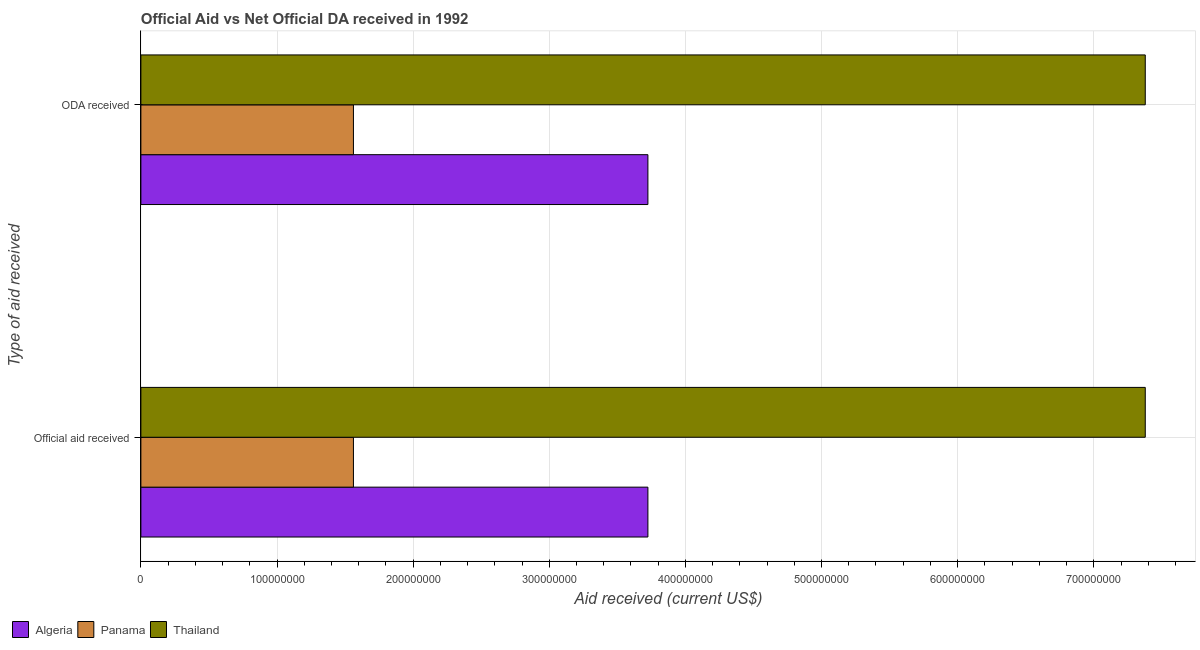How many different coloured bars are there?
Your answer should be compact. 3. How many groups of bars are there?
Give a very brief answer. 2. Are the number of bars per tick equal to the number of legend labels?
Provide a succinct answer. Yes. What is the label of the 2nd group of bars from the top?
Offer a terse response. Official aid received. What is the oda received in Panama?
Make the answer very short. 1.56e+08. Across all countries, what is the maximum oda received?
Offer a terse response. 7.38e+08. Across all countries, what is the minimum oda received?
Ensure brevity in your answer.  1.56e+08. In which country was the official aid received maximum?
Your response must be concise. Thailand. In which country was the oda received minimum?
Offer a very short reply. Panama. What is the total official aid received in the graph?
Make the answer very short. 1.27e+09. What is the difference between the oda received in Panama and that in Algeria?
Your response must be concise. -2.16e+08. What is the difference between the oda received in Thailand and the official aid received in Algeria?
Give a very brief answer. 3.65e+08. What is the average official aid received per country?
Make the answer very short. 4.22e+08. What is the difference between the official aid received and oda received in Thailand?
Keep it short and to the point. 0. What is the ratio of the official aid received in Algeria to that in Panama?
Provide a short and direct response. 2.39. Is the official aid received in Thailand less than that in Panama?
Your answer should be compact. No. What does the 2nd bar from the top in Official aid received represents?
Offer a terse response. Panama. What does the 2nd bar from the bottom in ODA received represents?
Provide a short and direct response. Panama. How many countries are there in the graph?
Provide a short and direct response. 3. What is the difference between two consecutive major ticks on the X-axis?
Your answer should be very brief. 1.00e+08. Does the graph contain grids?
Give a very brief answer. Yes. Where does the legend appear in the graph?
Keep it short and to the point. Bottom left. How are the legend labels stacked?
Offer a very short reply. Horizontal. What is the title of the graph?
Your answer should be very brief. Official Aid vs Net Official DA received in 1992 . Does "Morocco" appear as one of the legend labels in the graph?
Your answer should be very brief. No. What is the label or title of the X-axis?
Keep it short and to the point. Aid received (current US$). What is the label or title of the Y-axis?
Offer a terse response. Type of aid received. What is the Aid received (current US$) in Algeria in Official aid received?
Provide a succinct answer. 3.72e+08. What is the Aid received (current US$) of Panama in Official aid received?
Offer a terse response. 1.56e+08. What is the Aid received (current US$) in Thailand in Official aid received?
Ensure brevity in your answer.  7.38e+08. What is the Aid received (current US$) of Algeria in ODA received?
Provide a short and direct response. 3.72e+08. What is the Aid received (current US$) in Panama in ODA received?
Keep it short and to the point. 1.56e+08. What is the Aid received (current US$) in Thailand in ODA received?
Your answer should be very brief. 7.38e+08. Across all Type of aid received, what is the maximum Aid received (current US$) of Algeria?
Provide a succinct answer. 3.72e+08. Across all Type of aid received, what is the maximum Aid received (current US$) of Panama?
Keep it short and to the point. 1.56e+08. Across all Type of aid received, what is the maximum Aid received (current US$) in Thailand?
Provide a succinct answer. 7.38e+08. Across all Type of aid received, what is the minimum Aid received (current US$) in Algeria?
Offer a very short reply. 3.72e+08. Across all Type of aid received, what is the minimum Aid received (current US$) in Panama?
Provide a short and direct response. 1.56e+08. Across all Type of aid received, what is the minimum Aid received (current US$) of Thailand?
Offer a very short reply. 7.38e+08. What is the total Aid received (current US$) in Algeria in the graph?
Your answer should be very brief. 7.45e+08. What is the total Aid received (current US$) of Panama in the graph?
Give a very brief answer. 3.12e+08. What is the total Aid received (current US$) in Thailand in the graph?
Your answer should be very brief. 1.48e+09. What is the difference between the Aid received (current US$) in Algeria in Official aid received and the Aid received (current US$) in Panama in ODA received?
Provide a short and direct response. 2.16e+08. What is the difference between the Aid received (current US$) of Algeria in Official aid received and the Aid received (current US$) of Thailand in ODA received?
Offer a terse response. -3.65e+08. What is the difference between the Aid received (current US$) in Panama in Official aid received and the Aid received (current US$) in Thailand in ODA received?
Make the answer very short. -5.82e+08. What is the average Aid received (current US$) of Algeria per Type of aid received?
Your answer should be very brief. 3.72e+08. What is the average Aid received (current US$) of Panama per Type of aid received?
Provide a succinct answer. 1.56e+08. What is the average Aid received (current US$) of Thailand per Type of aid received?
Offer a terse response. 7.38e+08. What is the difference between the Aid received (current US$) of Algeria and Aid received (current US$) of Panama in Official aid received?
Offer a terse response. 2.16e+08. What is the difference between the Aid received (current US$) of Algeria and Aid received (current US$) of Thailand in Official aid received?
Keep it short and to the point. -3.65e+08. What is the difference between the Aid received (current US$) of Panama and Aid received (current US$) of Thailand in Official aid received?
Ensure brevity in your answer.  -5.82e+08. What is the difference between the Aid received (current US$) of Algeria and Aid received (current US$) of Panama in ODA received?
Ensure brevity in your answer.  2.16e+08. What is the difference between the Aid received (current US$) of Algeria and Aid received (current US$) of Thailand in ODA received?
Offer a terse response. -3.65e+08. What is the difference between the Aid received (current US$) in Panama and Aid received (current US$) in Thailand in ODA received?
Your response must be concise. -5.82e+08. What is the ratio of the Aid received (current US$) of Panama in Official aid received to that in ODA received?
Your response must be concise. 1. What is the ratio of the Aid received (current US$) of Thailand in Official aid received to that in ODA received?
Keep it short and to the point. 1. What is the difference between the highest and the second highest Aid received (current US$) in Panama?
Your answer should be compact. 0. 